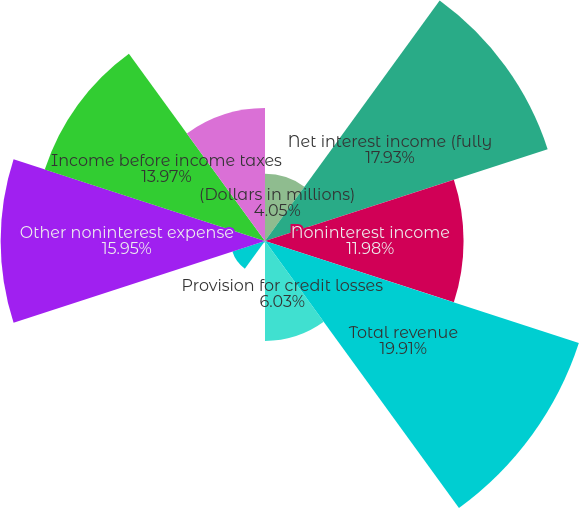Convert chart. <chart><loc_0><loc_0><loc_500><loc_500><pie_chart><fcel>(Dollars in millions)<fcel>Net interest income (fully<fcel>Noninterest income<fcel>Total revenue<fcel>Provision for credit losses<fcel>Gains on sales of debt<fcel>Amortization of intangibles<fcel>Other noninterest expense<fcel>Income before income taxes<fcel>Income tax expense<nl><fcel>4.05%<fcel>17.93%<fcel>11.98%<fcel>19.91%<fcel>6.03%<fcel>0.09%<fcel>2.07%<fcel>15.95%<fcel>13.97%<fcel>8.02%<nl></chart> 